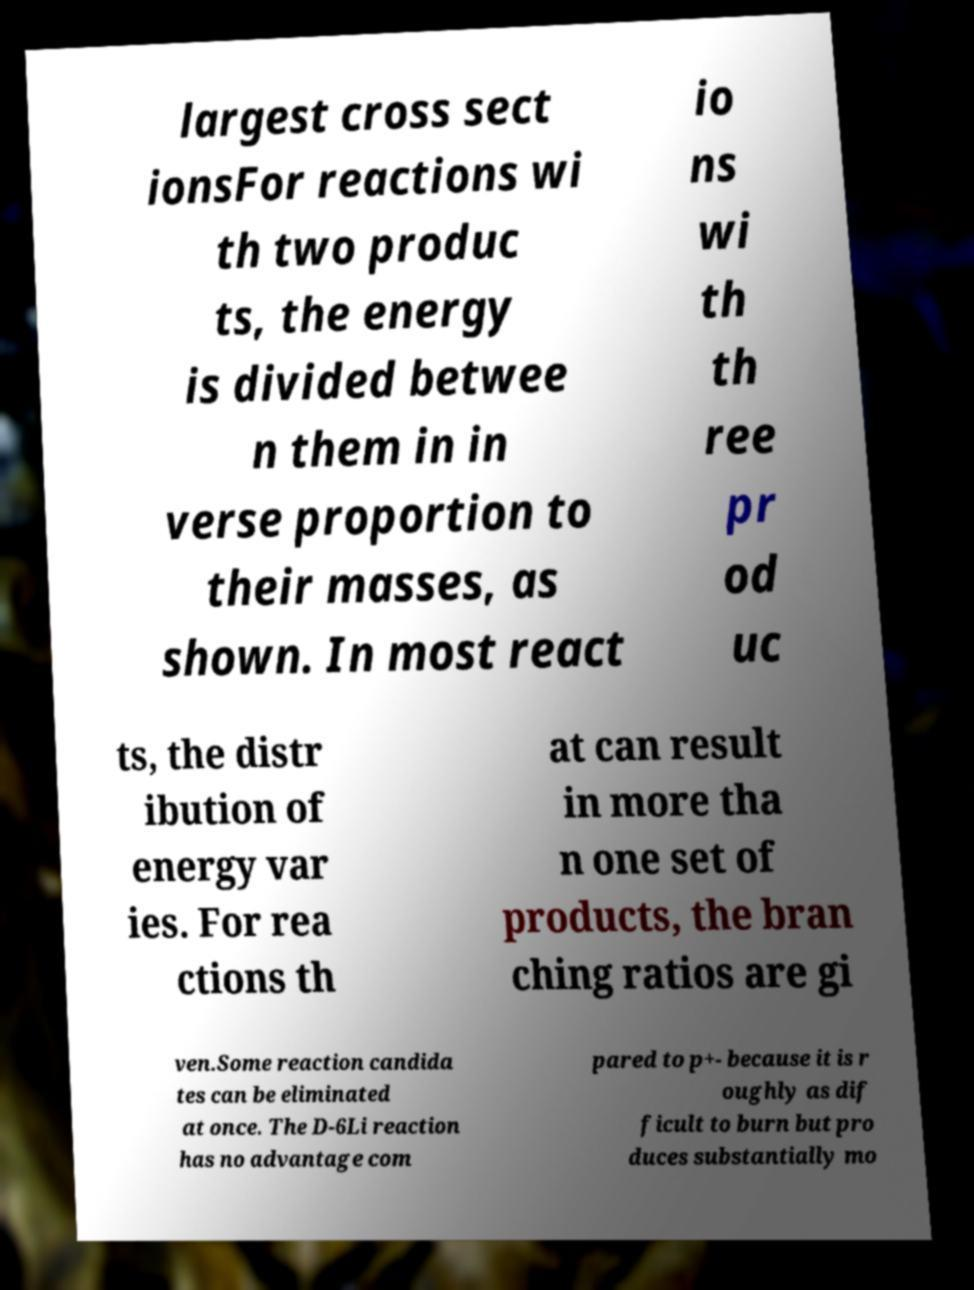Please read and relay the text visible in this image. What does it say? largest cross sect ionsFor reactions wi th two produc ts, the energy is divided betwee n them in in verse proportion to their masses, as shown. In most react io ns wi th th ree pr od uc ts, the distr ibution of energy var ies. For rea ctions th at can result in more tha n one set of products, the bran ching ratios are gi ven.Some reaction candida tes can be eliminated at once. The D-6Li reaction has no advantage com pared to p+- because it is r oughly as dif ficult to burn but pro duces substantially mo 